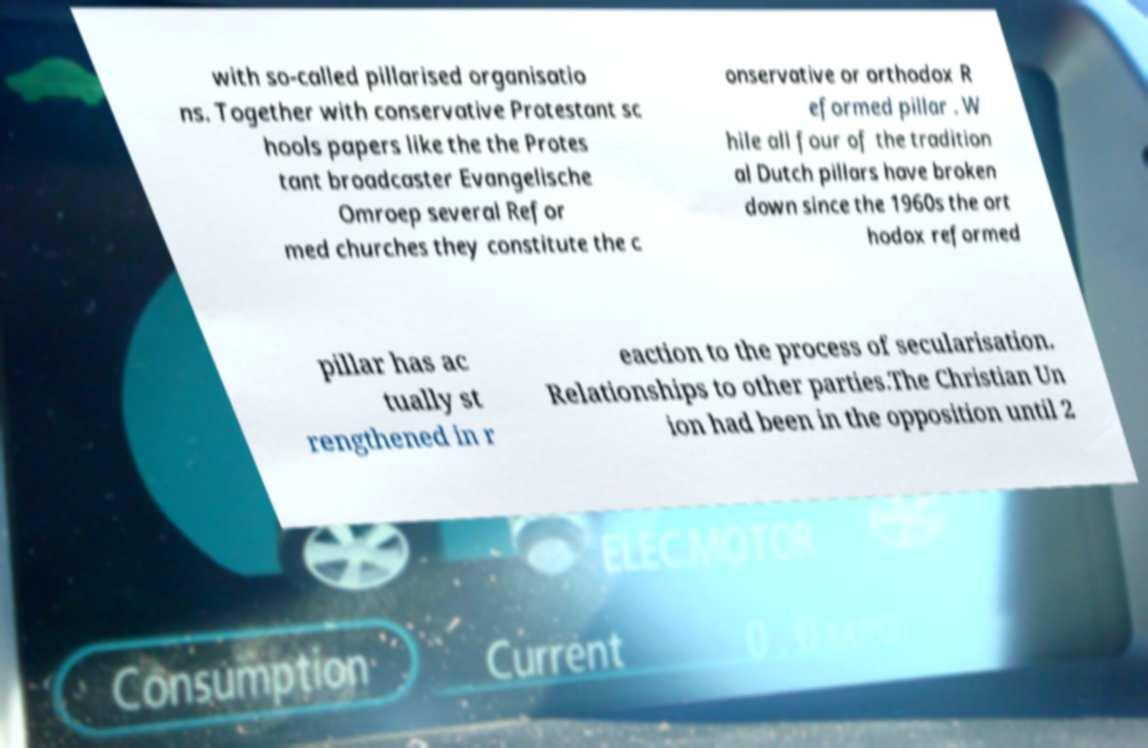Please identify and transcribe the text found in this image. with so-called pillarised organisatio ns. Together with conservative Protestant sc hools papers like the the Protes tant broadcaster Evangelische Omroep several Refor med churches they constitute the c onservative or orthodox R eformed pillar . W hile all four of the tradition al Dutch pillars have broken down since the 1960s the ort hodox reformed pillar has ac tually st rengthened in r eaction to the process of secularisation. Relationships to other parties.The Christian Un ion had been in the opposition until 2 